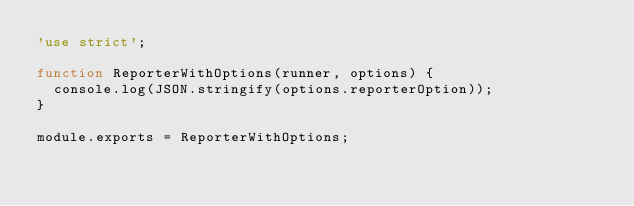Convert code to text. <code><loc_0><loc_0><loc_500><loc_500><_JavaScript_>'use strict';

function ReporterWithOptions(runner, options) {
  console.log(JSON.stringify(options.reporterOption));
}

module.exports = ReporterWithOptions;
</code> 